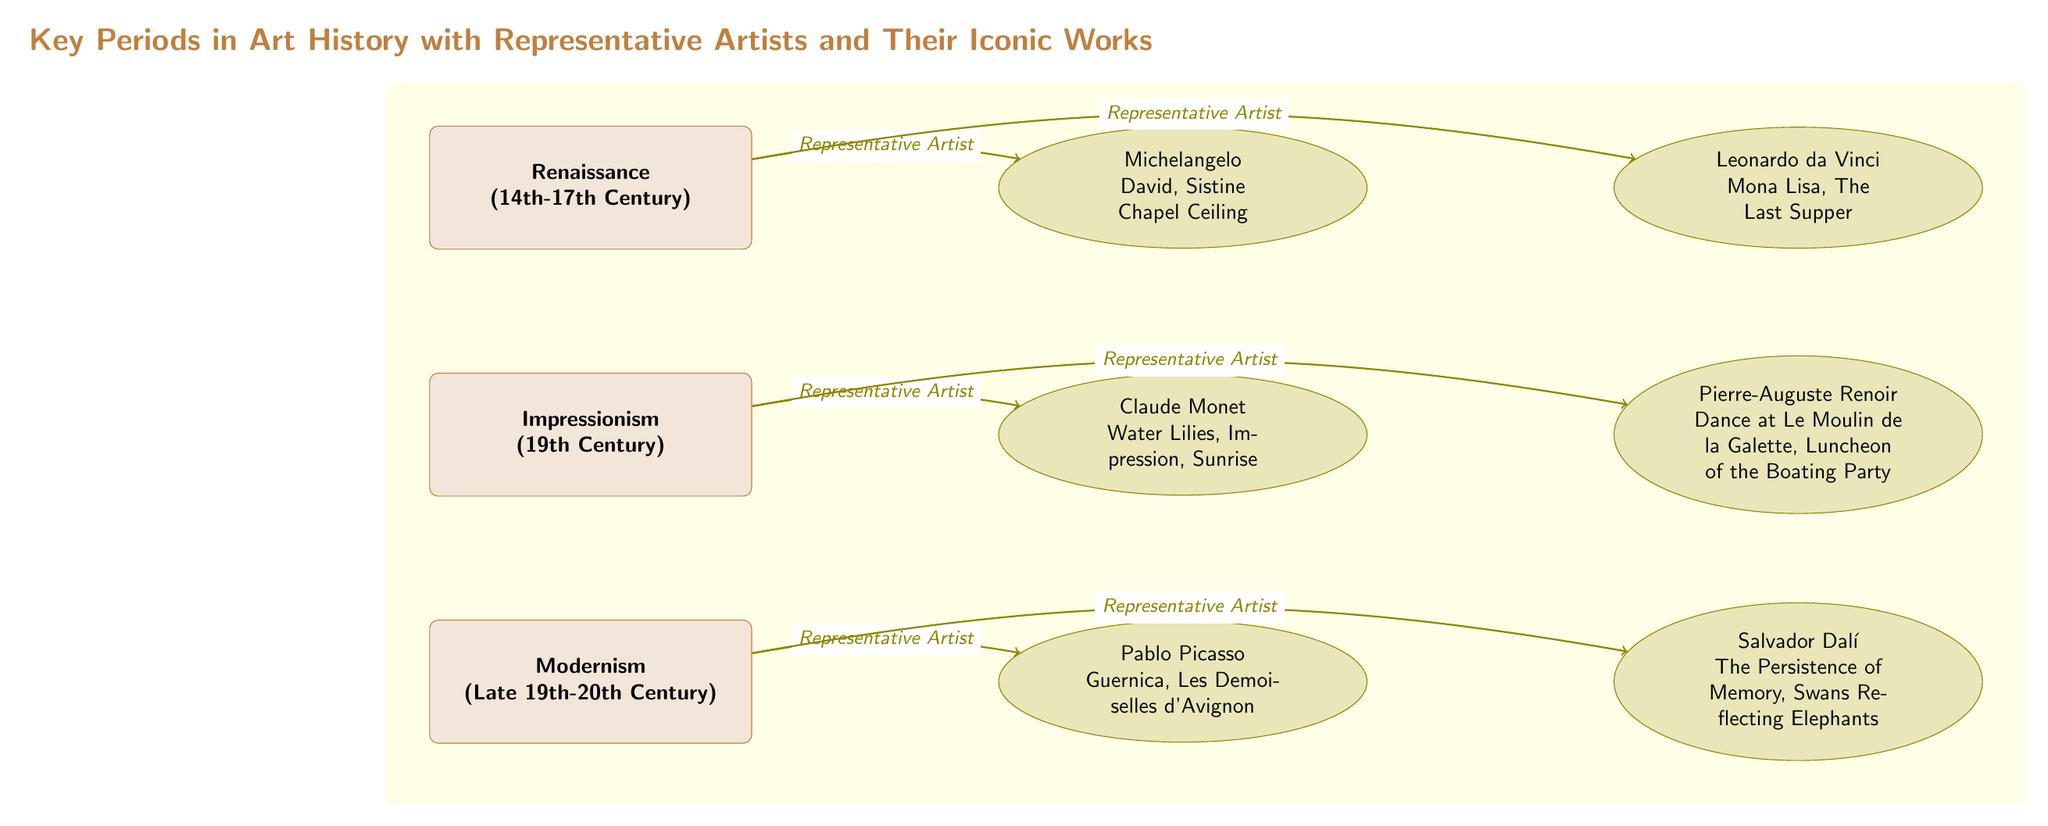What art period does Michelangelo belong to? By examining the diagram, I see that Michelangelo is connected to the Renaissance period. The edge label clearly states his association, confirming that he is a representative artist of this period.
Answer: Renaissance How many artists are associated with Impressionism? In the diagram, I look specifically under the Impressionism period node. There are two artists (Claude Monet and Pierre-Auguste Renoir) connected to this period, which I can count directly as I look at the edges connected to it.
Answer: 2 Which iconic work is associated with Picasso? The diagram shows the node connected to Pablo Picasso and lists "Guernica" and "Les Demoiselles d'Avignon" as his iconic works. I can directly read this information from the artist's label.
Answer: Guernica, Les Demoiselles d'Avignon What is the relationship between the Modernism period and Salvador Dalí? The edge connecting Modernism to Salvador Dalí indicates that he is a representative artist of the Modernism period. This shows a direct relationship between the artwork of this era and the artist.
Answer: Representative Artist Which artist is known for the "Mona Lisa"? According to the diagram, Leonardo da Vinci is the artist associated with the "Mona Lisa." He is explicitly mentioned in the connected node under the Renaissance period.
Answer: Leonardo da Vinci What are the two iconic works of Claude Monet? The diagram clearly lists "Water Lilies" and "Impression, Sunrise" next to Claude Monet's name in the Impressionism section. I can confirm these works as they are both displayed in his respective node.
Answer: Water Lilies, Impression, Sunrise How many key periods in art history are shown in the diagram? By reviewing the diagram, I note that there are three key periods depicted: Renaissance, Impressionism, and Modernism. This is directly observable from the main period nodes present.
Answer: 3 Who is the artist associated with "The Persistence of Memory"? In the diagram, under the Modernism section, Salvador Dalí is listed with "The Persistence of Memory" as one of his works. This connection allows me to identify him as the artist associated with this specific artwork.
Answer: Salvador Dalí What does the yellow background in the diagram represent? The yellow background encompasses the entire area with the three main artistic periods. It serves to visually group the key periods in art history along with their representative artists and works, making the diagram more organized and easier to read.
Answer: Grouping of key periods 